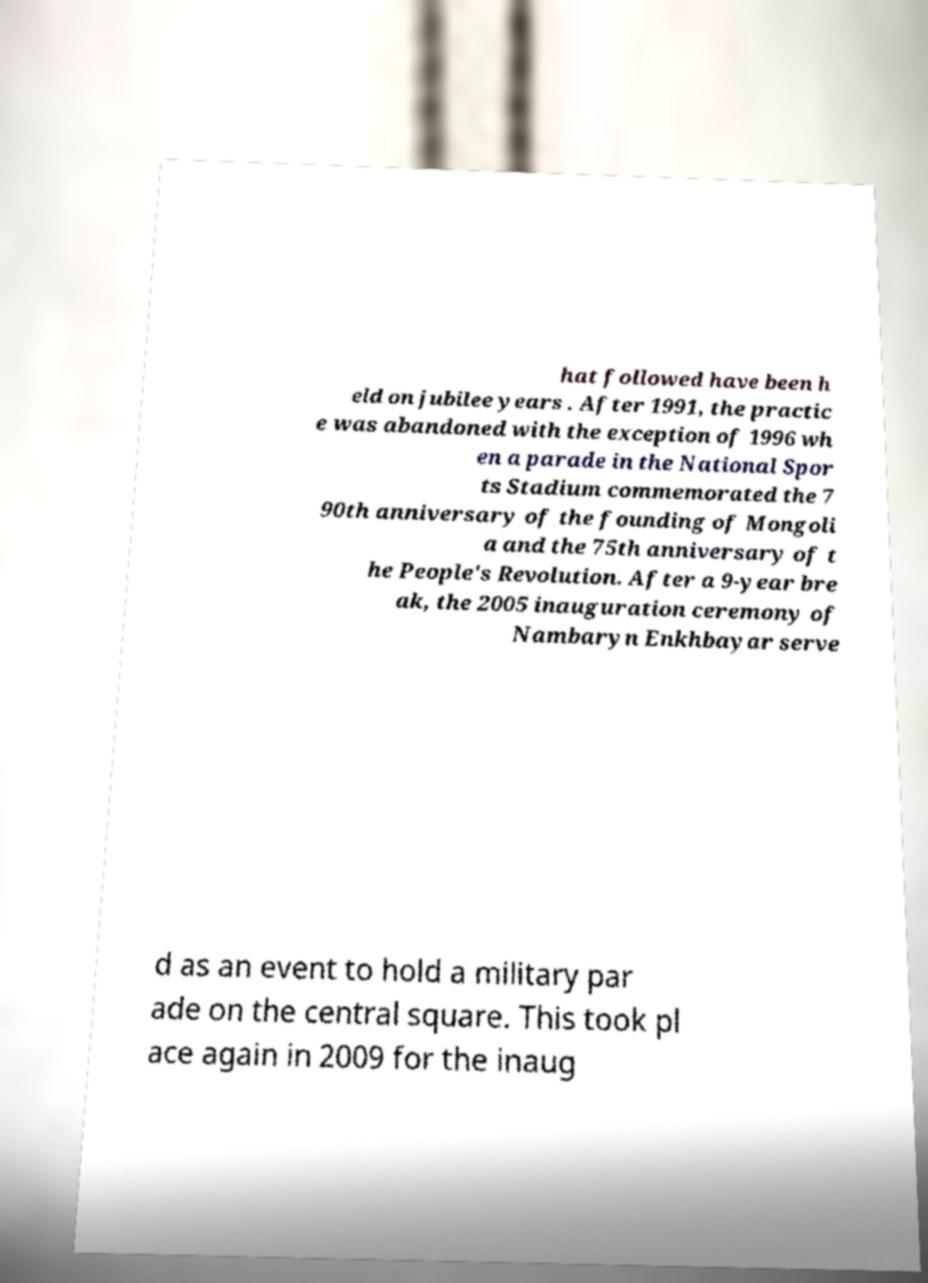Could you extract and type out the text from this image? hat followed have been h eld on jubilee years . After 1991, the practic e was abandoned with the exception of 1996 wh en a parade in the National Spor ts Stadium commemorated the 7 90th anniversary of the founding of Mongoli a and the 75th anniversary of t he People's Revolution. After a 9-year bre ak, the 2005 inauguration ceremony of Nambaryn Enkhbayar serve d as an event to hold a military par ade on the central square. This took pl ace again in 2009 for the inaug 